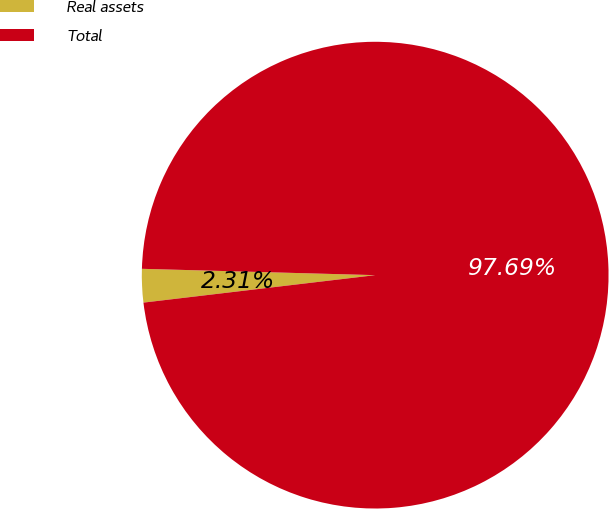<chart> <loc_0><loc_0><loc_500><loc_500><pie_chart><fcel>Real assets<fcel>Total<nl><fcel>2.31%<fcel>97.69%<nl></chart> 